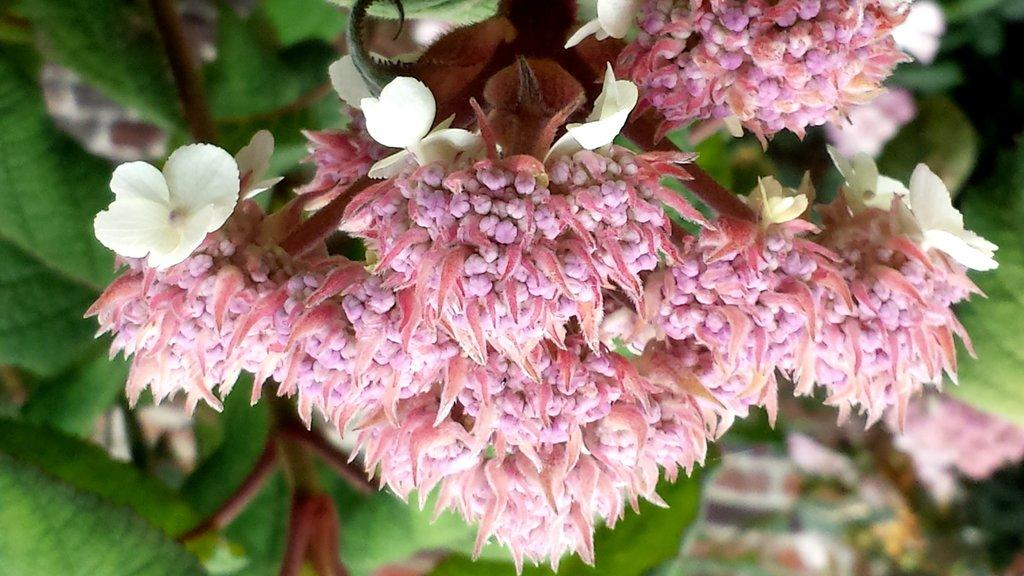What can be seen in the foreground of the picture? There are flowers in the foreground of the picture. How would you describe the background of the image? The background of the image is blurred. What else can be found in the background of the image besides the blurred area? There are leaves and flowers in the background of the image. What type of cork can be seen in the image? There is no cork present in the image. How many family members are visible in the image? There is no reference to family members in the image, as it primarily features flowers and leaves. 